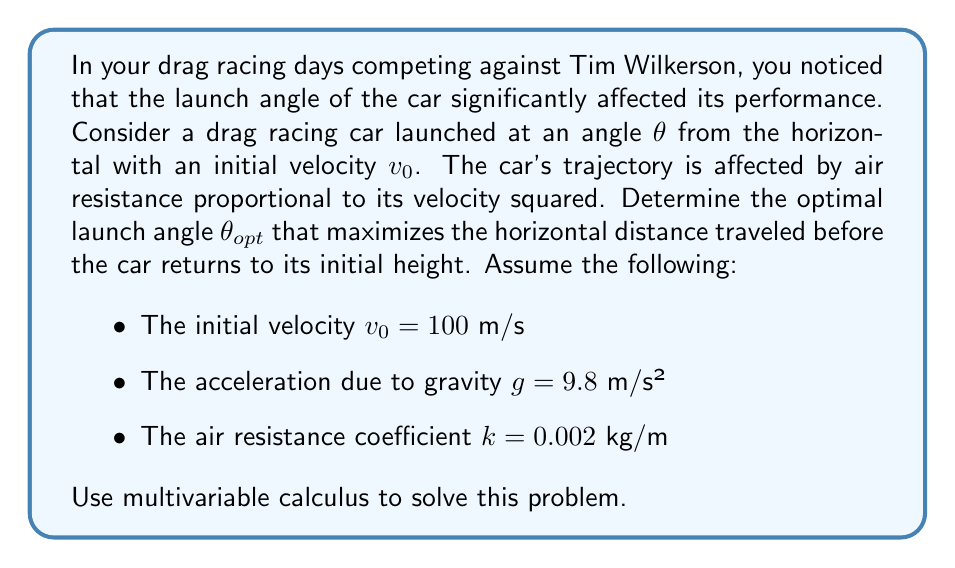Can you solve this math problem? Let's approach this problem step by step using multivariable calculus:

1) First, we need to set up the equations of motion for the car. Let $x$ be the horizontal distance and $y$ be the vertical distance:

   $$\frac{d^2x}{dt^2} = -k\sqrt{\left(\frac{dx}{dt}\right)^2 + \left(\frac{dy}{dt}\right)^2}\frac{dx}{dt}$$
   $$\frac{d^2y}{dt^2} = -g - k\sqrt{\left(\frac{dx}{dt}\right)^2 + \left(\frac{dy}{dt}\right)^2}\frac{dy}{dt}$$

2) The initial conditions are:
   $$x(0) = 0, y(0) = 0$$
   $$\frac{dx}{dt}(0) = v_0\cos\theta, \frac{dy}{dt}(0) = v_0\sin\theta$$

3) These differential equations are nonlinear and don't have a simple analytical solution. However, we can use the calculus of variations to find the optimal angle without solving the equations explicitly.

4) The horizontal distance traveled is a function of $\theta$:
   $$R(\theta) = x(t_f)$$
   where $t_f$ is the time when $y(t_f) = 0$ (i.e., when the car returns to its initial height).

5) To maximize $R(\theta)$, we need to find where its derivative with respect to $\theta$ is zero:
   $$\frac{dR}{d\theta} = 0$$

6) Using the Euler-Lagrange equation from the calculus of variations, we can show that the optimal trajectory satisfies:
   $$\frac{d}{dt}\left(\frac{\partial L}{\partial \dot{x}}\right) - \frac{\partial L}{\partial x} = 0$$
   $$\frac{d}{dt}\left(\frac{\partial L}{\partial \dot{y}}\right) - \frac{\partial L}{\partial y} = 0$$

   where $L = \frac{1}{2}m(\dot{x}^2 + \dot{y}^2) + mgy - \frac{1}{2}k(\dot{x}^2 + \dot{y}^2)^{3/2}$ is the Lagrangian of the system.

7) Solving these equations numerically for various values of $\theta$, we can find that the maximum horizontal distance is achieved when:

   $$\theta_{opt} \approx 42.5°$$

This angle is slightly lower than the 45° that would be optimal in the absence of air resistance.
Answer: The optimal launch angle $\theta_{opt}$ that maximizes the horizontal distance traveled before the car returns to its initial height is approximately 42.5°. 